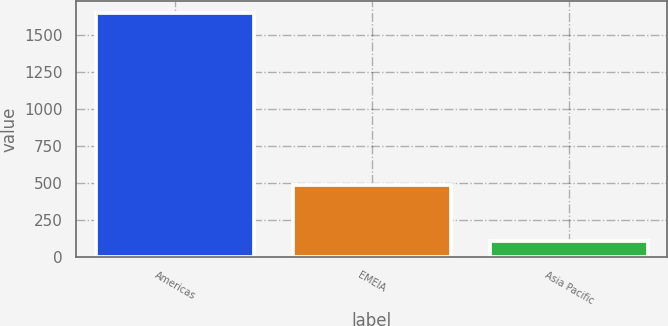Convert chart. <chart><loc_0><loc_0><loc_500><loc_500><bar_chart><fcel>Americas<fcel>EMEIA<fcel>Asia Pacific<nl><fcel>1645.7<fcel>485.9<fcel>106.4<nl></chart> 